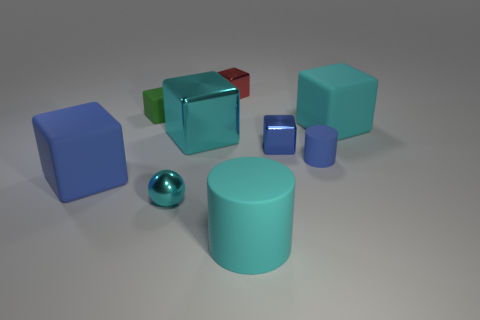Subtract all blue balls. How many cyan blocks are left? 2 Subtract all red blocks. How many blocks are left? 5 Subtract all cyan rubber blocks. How many blocks are left? 5 Subtract 3 cubes. How many cubes are left? 3 Add 1 brown rubber cylinders. How many objects exist? 10 Subtract all cylinders. How many objects are left? 7 Subtract all blue cubes. Subtract all red cylinders. How many cubes are left? 4 Add 7 big blue cubes. How many big blue cubes are left? 8 Add 1 brown rubber blocks. How many brown rubber blocks exist? 1 Subtract 0 blue balls. How many objects are left? 9 